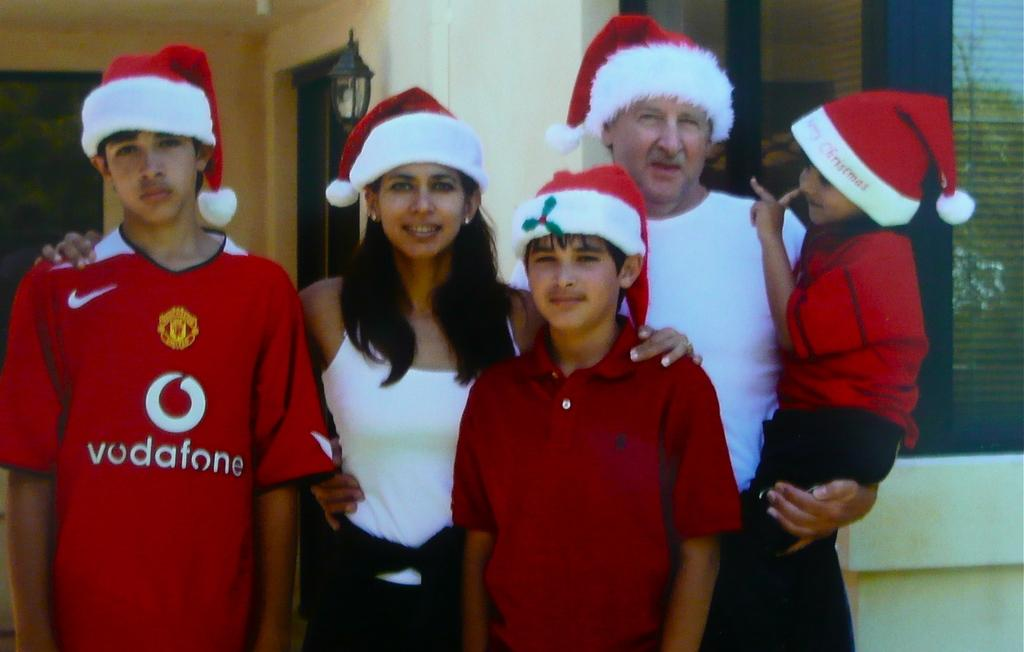Provide a one-sentence caption for the provided image. Five people pose for a photograph, one of whom is wearing a vodafone t-shirt. 